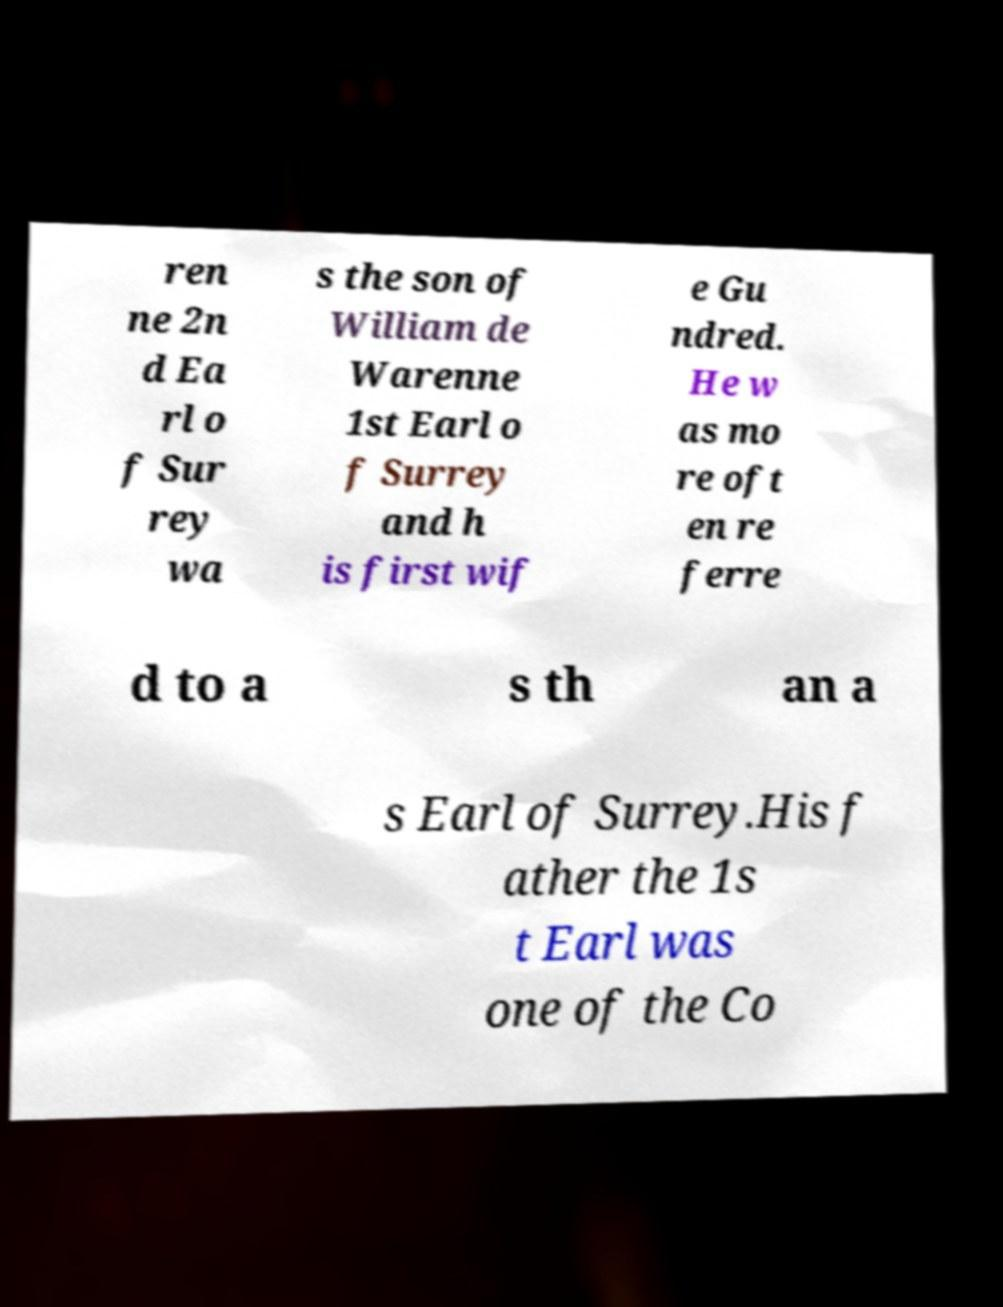I need the written content from this picture converted into text. Can you do that? ren ne 2n d Ea rl o f Sur rey wa s the son of William de Warenne 1st Earl o f Surrey and h is first wif e Gu ndred. He w as mo re oft en re ferre d to a s th an a s Earl of Surrey.His f ather the 1s t Earl was one of the Co 